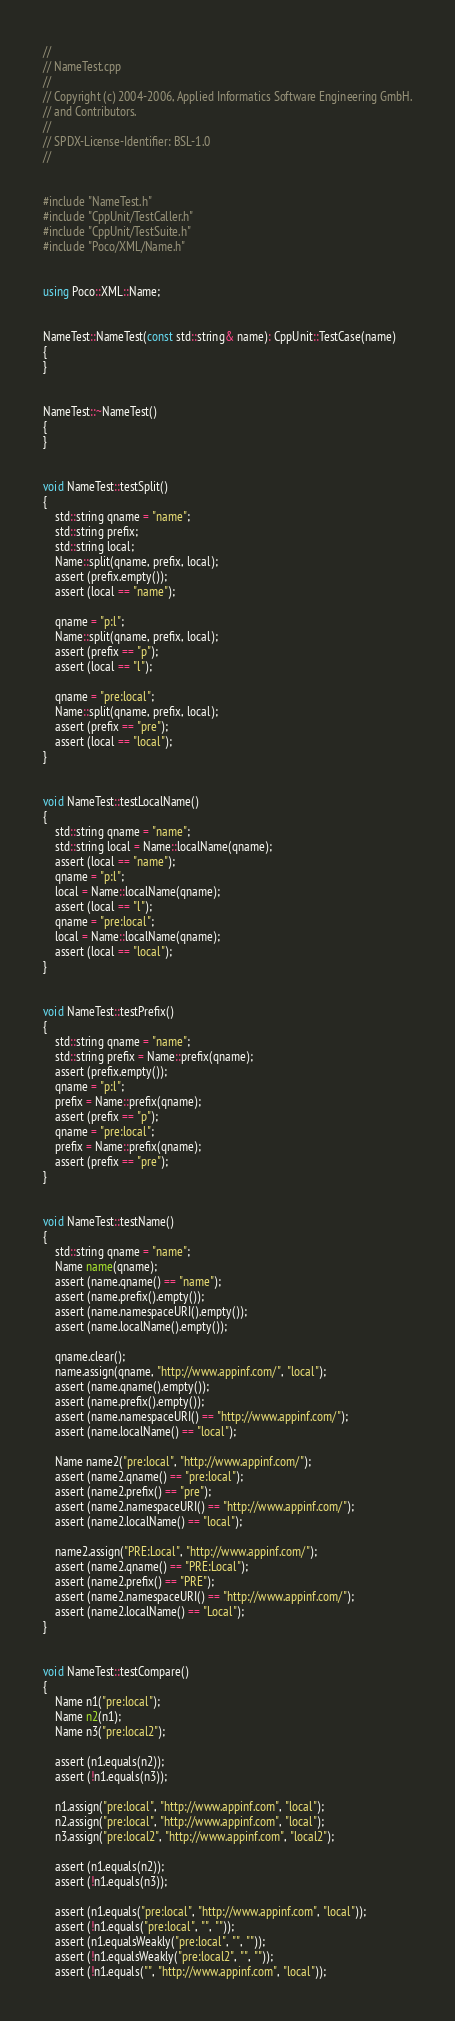<code> <loc_0><loc_0><loc_500><loc_500><_C++_>//
// NameTest.cpp
//
// Copyright (c) 2004-2006, Applied Informatics Software Engineering GmbH.
// and Contributors.
//
// SPDX-License-Identifier:	BSL-1.0
//


#include "NameTest.h"
#include "CppUnit/TestCaller.h"
#include "CppUnit/TestSuite.h"
#include "Poco/XML/Name.h"


using Poco::XML::Name;


NameTest::NameTest(const std::string& name): CppUnit::TestCase(name)
{
}


NameTest::~NameTest()
{
}


void NameTest::testSplit()
{
	std::string qname = "name";
	std::string prefix;
	std::string local;
	Name::split(qname, prefix, local);
	assert (prefix.empty());
	assert (local == "name");
	
	qname = "p:l";
	Name::split(qname, prefix, local);
	assert (prefix == "p");
	assert (local == "l");
	
	qname = "pre:local";
	Name::split(qname, prefix, local);
	assert (prefix == "pre");
	assert (local == "local");
}


void NameTest::testLocalName()
{
	std::string qname = "name";
	std::string local = Name::localName(qname);
	assert (local == "name");
	qname = "p:l";
	local = Name::localName(qname);
	assert (local == "l");
	qname = "pre:local";
	local = Name::localName(qname);
	assert (local == "local");
}


void NameTest::testPrefix()
{
	std::string qname = "name";
	std::string prefix = Name::prefix(qname);
	assert (prefix.empty());
	qname = "p:l";
	prefix = Name::prefix(qname);
	assert (prefix == "p");
	qname = "pre:local";
	prefix = Name::prefix(qname);
	assert (prefix == "pre");
}


void NameTest::testName()
{
	std::string qname = "name";
	Name name(qname);
	assert (name.qname() == "name");
	assert (name.prefix().empty());
	assert (name.namespaceURI().empty());
	assert (name.localName().empty());

	qname.clear();
	name.assign(qname, "http://www.appinf.com/", "local");
	assert (name.qname().empty());
	assert (name.prefix().empty());
	assert (name.namespaceURI() == "http://www.appinf.com/");
	assert (name.localName() == "local");

	Name name2("pre:local", "http://www.appinf.com/");
	assert (name2.qname() == "pre:local");
	assert (name2.prefix() == "pre");
	assert (name2.namespaceURI() == "http://www.appinf.com/");
	assert (name2.localName() == "local");

	name2.assign("PRE:Local", "http://www.appinf.com/");
	assert (name2.qname() == "PRE:Local");
	assert (name2.prefix() == "PRE");
	assert (name2.namespaceURI() == "http://www.appinf.com/");
	assert (name2.localName() == "Local");
}


void NameTest::testCompare()
{
	Name n1("pre:local");
	Name n2(n1);
	Name n3("pre:local2");
	
	assert (n1.equals(n2));
	assert (!n1.equals(n3));
	
	n1.assign("pre:local", "http://www.appinf.com", "local");
	n2.assign("pre:local", "http://www.appinf.com", "local");
	n3.assign("pre:local2", "http://www.appinf.com", "local2");
	
	assert (n1.equals(n2));
	assert (!n1.equals(n3));
	
	assert (n1.equals("pre:local", "http://www.appinf.com", "local"));
	assert (!n1.equals("pre:local", "", ""));
	assert (n1.equalsWeakly("pre:local", "", ""));
	assert (!n1.equalsWeakly("pre:local2", "", ""));
	assert (!n1.equals("", "http://www.appinf.com", "local"));</code> 